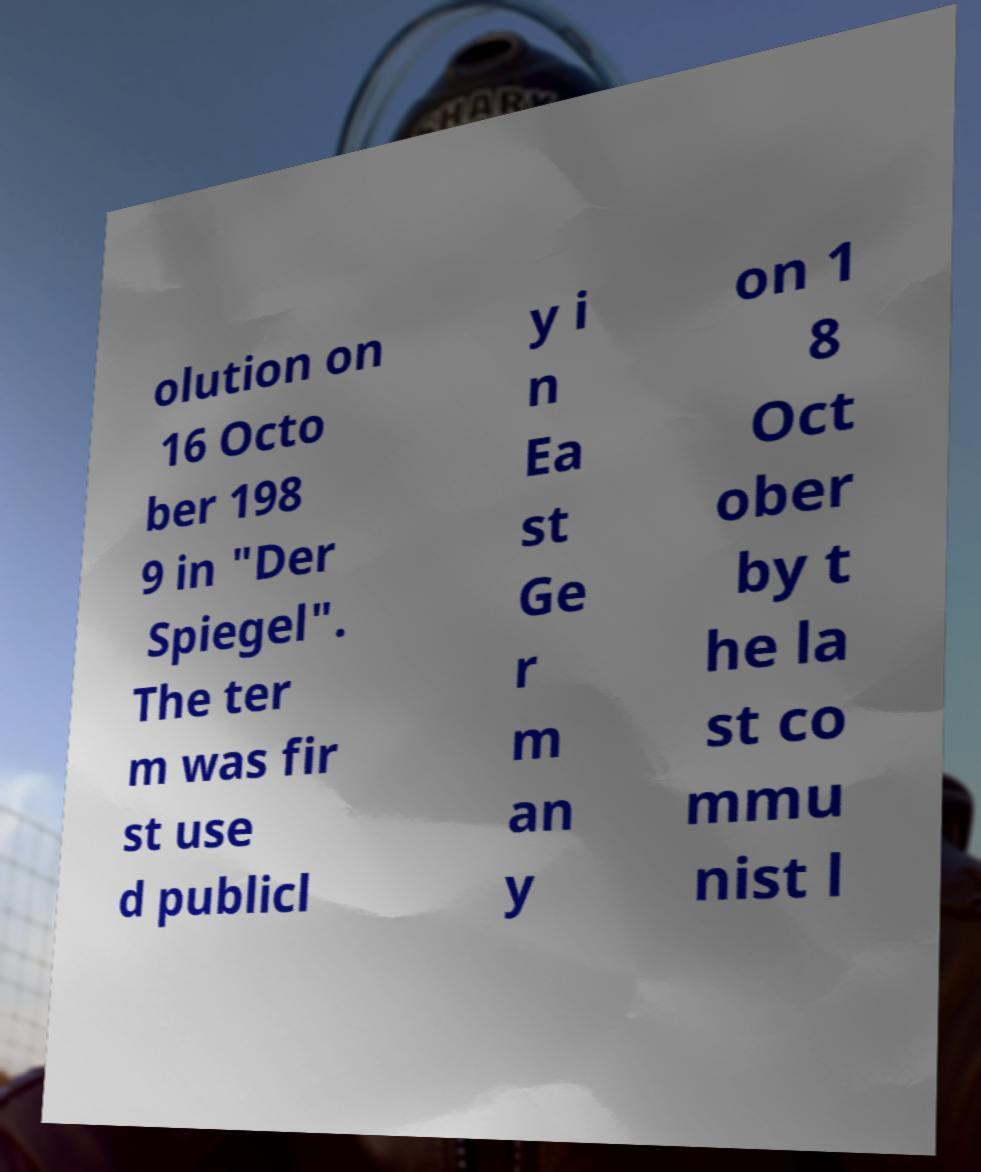Please identify and transcribe the text found in this image. olution on 16 Octo ber 198 9 in "Der Spiegel". The ter m was fir st use d publicl y i n Ea st Ge r m an y on 1 8 Oct ober by t he la st co mmu nist l 